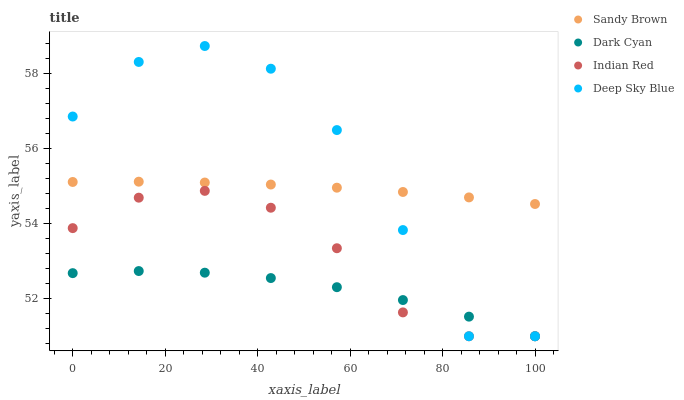Does Dark Cyan have the minimum area under the curve?
Answer yes or no. Yes. Does Deep Sky Blue have the maximum area under the curve?
Answer yes or no. Yes. Does Sandy Brown have the minimum area under the curve?
Answer yes or no. No. Does Sandy Brown have the maximum area under the curve?
Answer yes or no. No. Is Sandy Brown the smoothest?
Answer yes or no. Yes. Is Deep Sky Blue the roughest?
Answer yes or no. Yes. Is Deep Sky Blue the smoothest?
Answer yes or no. No. Is Sandy Brown the roughest?
Answer yes or no. No. Does Dark Cyan have the lowest value?
Answer yes or no. Yes. Does Sandy Brown have the lowest value?
Answer yes or no. No. Does Deep Sky Blue have the highest value?
Answer yes or no. Yes. Does Sandy Brown have the highest value?
Answer yes or no. No. Is Indian Red less than Sandy Brown?
Answer yes or no. Yes. Is Sandy Brown greater than Indian Red?
Answer yes or no. Yes. Does Indian Red intersect Deep Sky Blue?
Answer yes or no. Yes. Is Indian Red less than Deep Sky Blue?
Answer yes or no. No. Is Indian Red greater than Deep Sky Blue?
Answer yes or no. No. Does Indian Red intersect Sandy Brown?
Answer yes or no. No. 